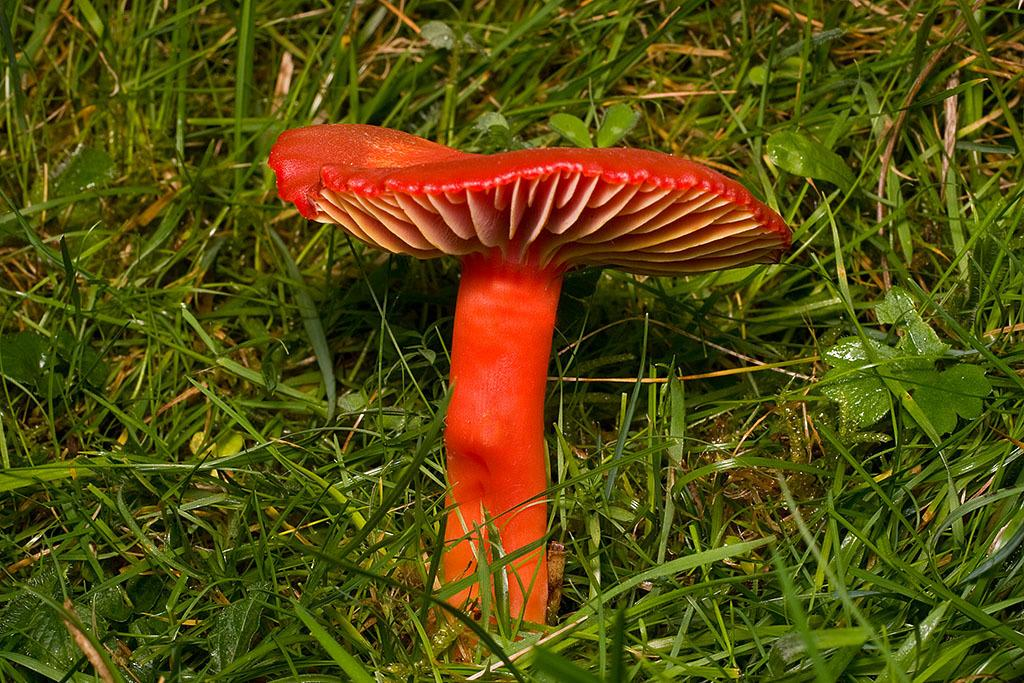What is the main subject of the image? There is a mushroom in the image. What can be seen behind the mushroom? There are leaves and grass behind the mushroom. What time of day is it in the image, and is there a crow or bike present? The time of day cannot be determined from the image, and there is no crow or bike present. 